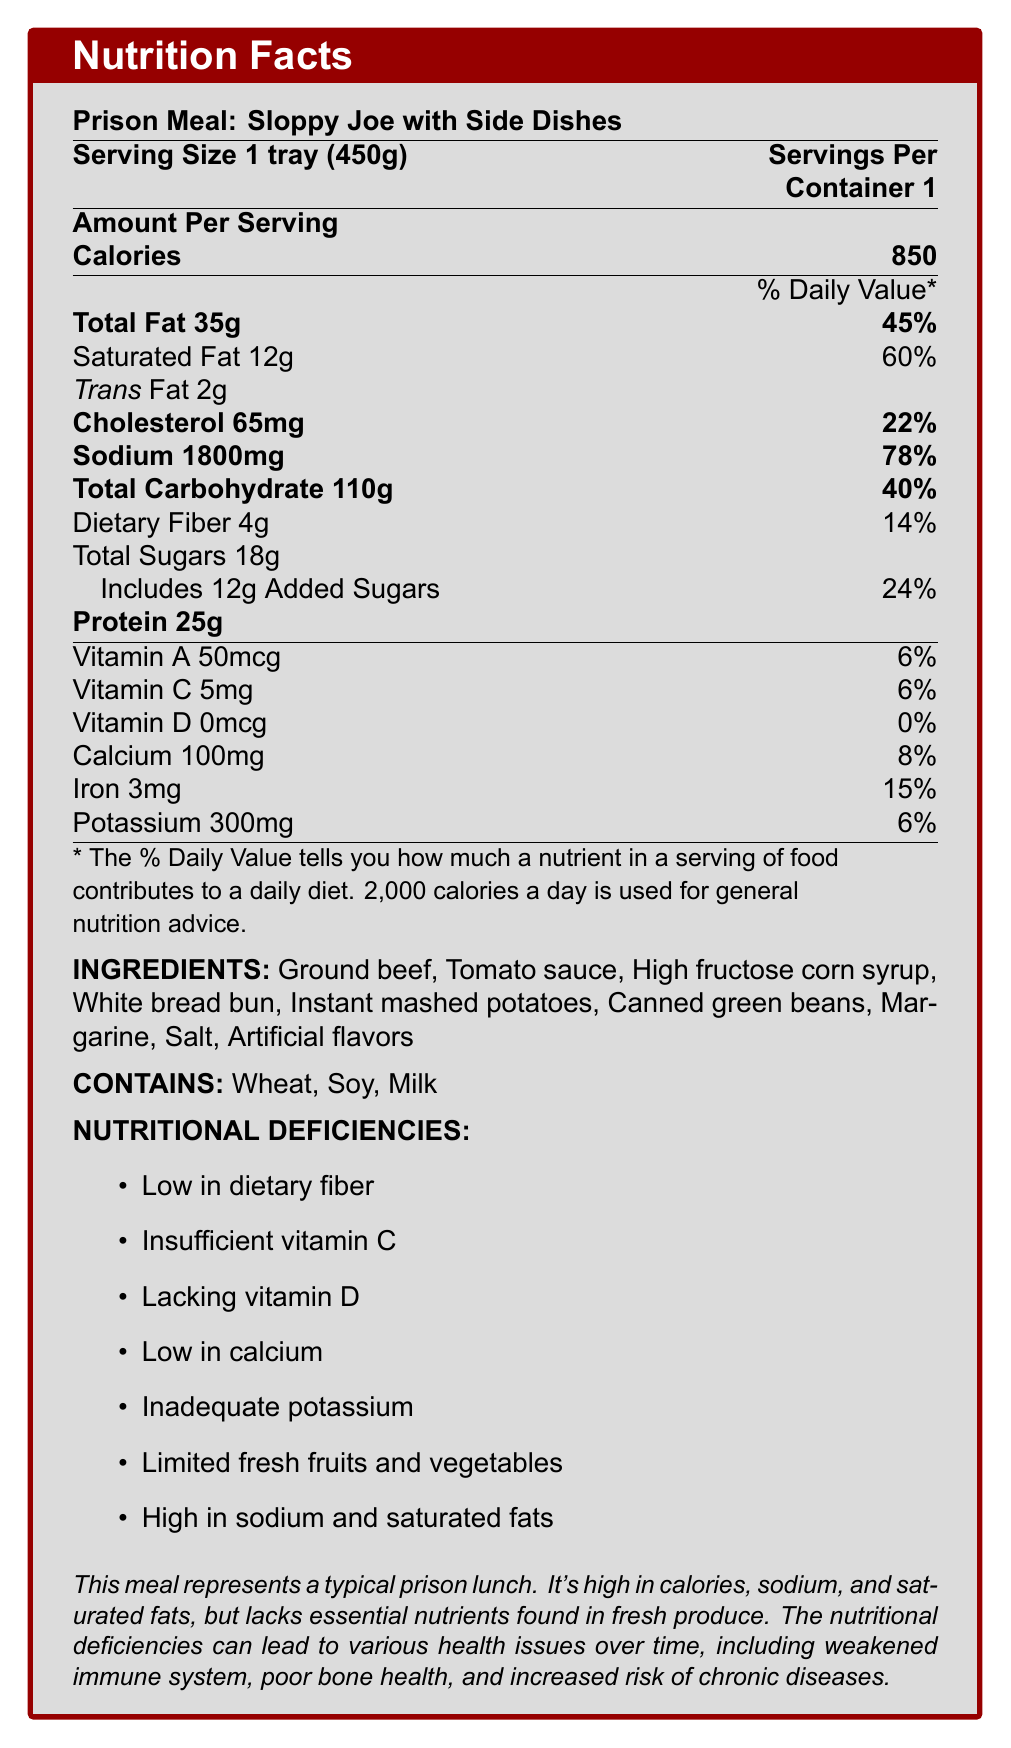what is the serving size of the prison meal? The serving size is directly listed as "1 tray (450g)".
Answer: 1 tray (450g) how many calories are in one serving of the meal? The document states that there are 850 calories per serving.
Answer: 850 calories what percentage of the daily value of saturated fat does one serving contain? The document indicates that one serving contains 60% of the daily value of saturated fat.
Answer: 60% how much dietary fiber is in one serving of the meal? According to the document, one serving of the meal contains 4g of dietary fiber.
Answer: 4g how many milligrams of sodium are in one serving? The document lists that one serving contains 1800mg of sodium.
Answer: 1800mg which of these vitamins is completely absent in this meal? A. Vitamin A B. Vitamin C C. Vitamin D D. Calcium The document states that the meal contains 0% of the daily value for Vitamin D, indicating it is completely absent.
Answer: C. Vitamin D what are some of the main ingredients in the meal? A. Ground beef, Tomato sauce, High fructose corn syrup B. Chicken, Brown rice, Fresh green beans C. Tofu, Whole wheat bread, Fresh vegetables The document lists ground beef, tomato sauce, and high fructose corn syrup as some of the main ingredients.
Answer: A. Ground beef, Tomato sauce, High fructose corn syrup is this meal high in sodium? The document states that one serving contains 1800mg of sodium, which is 78% of the daily value, indicating it is high.
Answer: Yes summarize the main nutritional deficiencies of this prison meal. The document specifies various nutritional deficiencies, including low dietary fiber, insufficient vitamins, lack of fresh produce, and high sodium and saturated fats.
Answer: The meal is low in dietary fiber, insufficient in vitamins C and D, low in calcium, inadequate in potassium, and limited in fresh fruits and vegetables. It is also high in sodium and saturated fats. what might be some health issues resulting from the nutritional deficiencies in this meal? The document mentions that long-term consumption of this meal can lead to weakened immune system, poor bone health, and increased risk of chronic diseases due to its nutritional deficiencies.
Answer: Weakened immune system, poor bone health, increased risk of chronic diseases how much protein does the meal provide? The document states that one serving contains 25g of protein.
Answer: 25g which allergens are present in this meal? The document lists wheat, soy, and milk as allergens contained in the meal.
Answer: Wheat, Soy, Milk how many grams of added sugars are in one serving? The document indicates that there are 12g of added sugars in one serving.
Answer: 12g what is one unlisted ingredient that could improve the nutritional quality of the meal? The document does not provide information on unlisted ingredients; therefore, this cannot be determined.
Answer: Cannot be determined what are the potential health risks associated with the high levels of sodium and saturated fats in this meal? The document mentions that the high sodium and saturated fat content can lead to increased risks of chronic diseases, such as high blood pressure, heart disease, and stroke.
Answer: Increased risk of high blood pressure, heart disease, and stroke which ingredient is not listed under nutritional deficiencies? A. Low in dietary fiber B. Insufficient vitamin C C. High protein D. Lacking vitamin D The document lists all deficiencies except for "high protein", which is not mentioned and, in fact, the meal provides substantial protein (25g).
Answer: C. High protein 